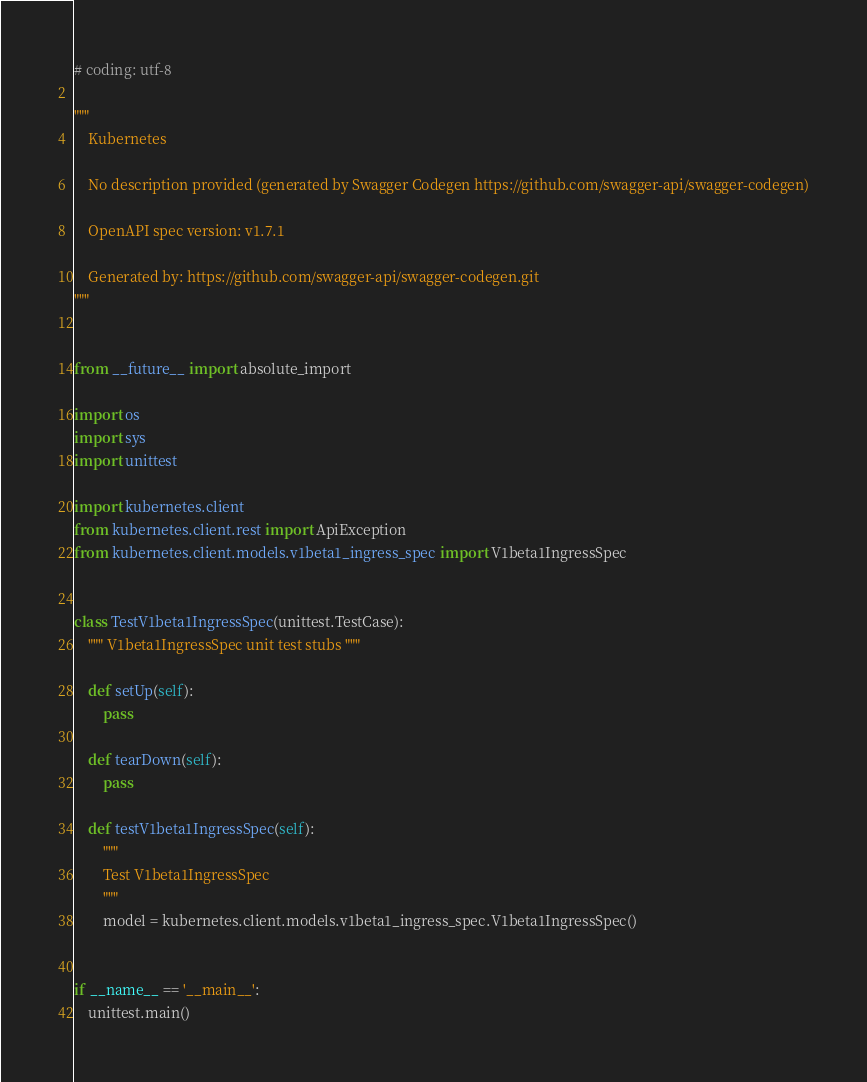Convert code to text. <code><loc_0><loc_0><loc_500><loc_500><_Python_># coding: utf-8

"""
    Kubernetes

    No description provided (generated by Swagger Codegen https://github.com/swagger-api/swagger-codegen)

    OpenAPI spec version: v1.7.1
    
    Generated by: https://github.com/swagger-api/swagger-codegen.git
"""


from __future__ import absolute_import

import os
import sys
import unittest

import kubernetes.client
from kubernetes.client.rest import ApiException
from kubernetes.client.models.v1beta1_ingress_spec import V1beta1IngressSpec


class TestV1beta1IngressSpec(unittest.TestCase):
    """ V1beta1IngressSpec unit test stubs """

    def setUp(self):
        pass

    def tearDown(self):
        pass

    def testV1beta1IngressSpec(self):
        """
        Test V1beta1IngressSpec
        """
        model = kubernetes.client.models.v1beta1_ingress_spec.V1beta1IngressSpec()


if __name__ == '__main__':
    unittest.main()
</code> 